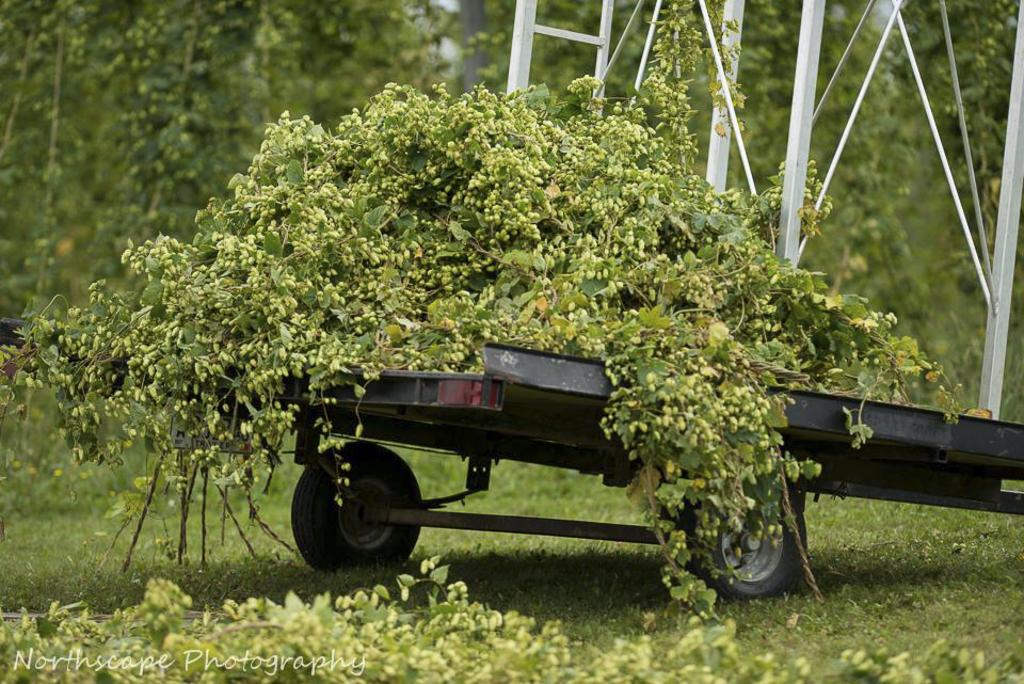What is located in the middle of the image? There are plants in the middle of the image. What can be seen in the bottom left side of the image? There is a watermark on the bottom left side of the image. What type of vegetation is visible in the background of the image? There are trees in the background of the image. Can you provide an example of a duck in the image? There is no duck present in the image; it features plants and trees. How does the watermark stretch across the image? The watermark is a stationary mark on the bottom left side of the image and does not stretch or move. 